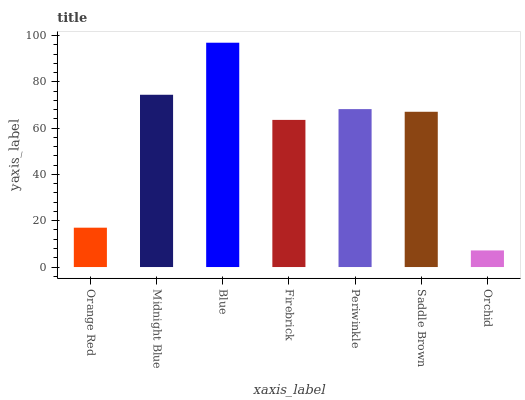Is Orchid the minimum?
Answer yes or no. Yes. Is Blue the maximum?
Answer yes or no. Yes. Is Midnight Blue the minimum?
Answer yes or no. No. Is Midnight Blue the maximum?
Answer yes or no. No. Is Midnight Blue greater than Orange Red?
Answer yes or no. Yes. Is Orange Red less than Midnight Blue?
Answer yes or no. Yes. Is Orange Red greater than Midnight Blue?
Answer yes or no. No. Is Midnight Blue less than Orange Red?
Answer yes or no. No. Is Saddle Brown the high median?
Answer yes or no. Yes. Is Saddle Brown the low median?
Answer yes or no. Yes. Is Orange Red the high median?
Answer yes or no. No. Is Blue the low median?
Answer yes or no. No. 